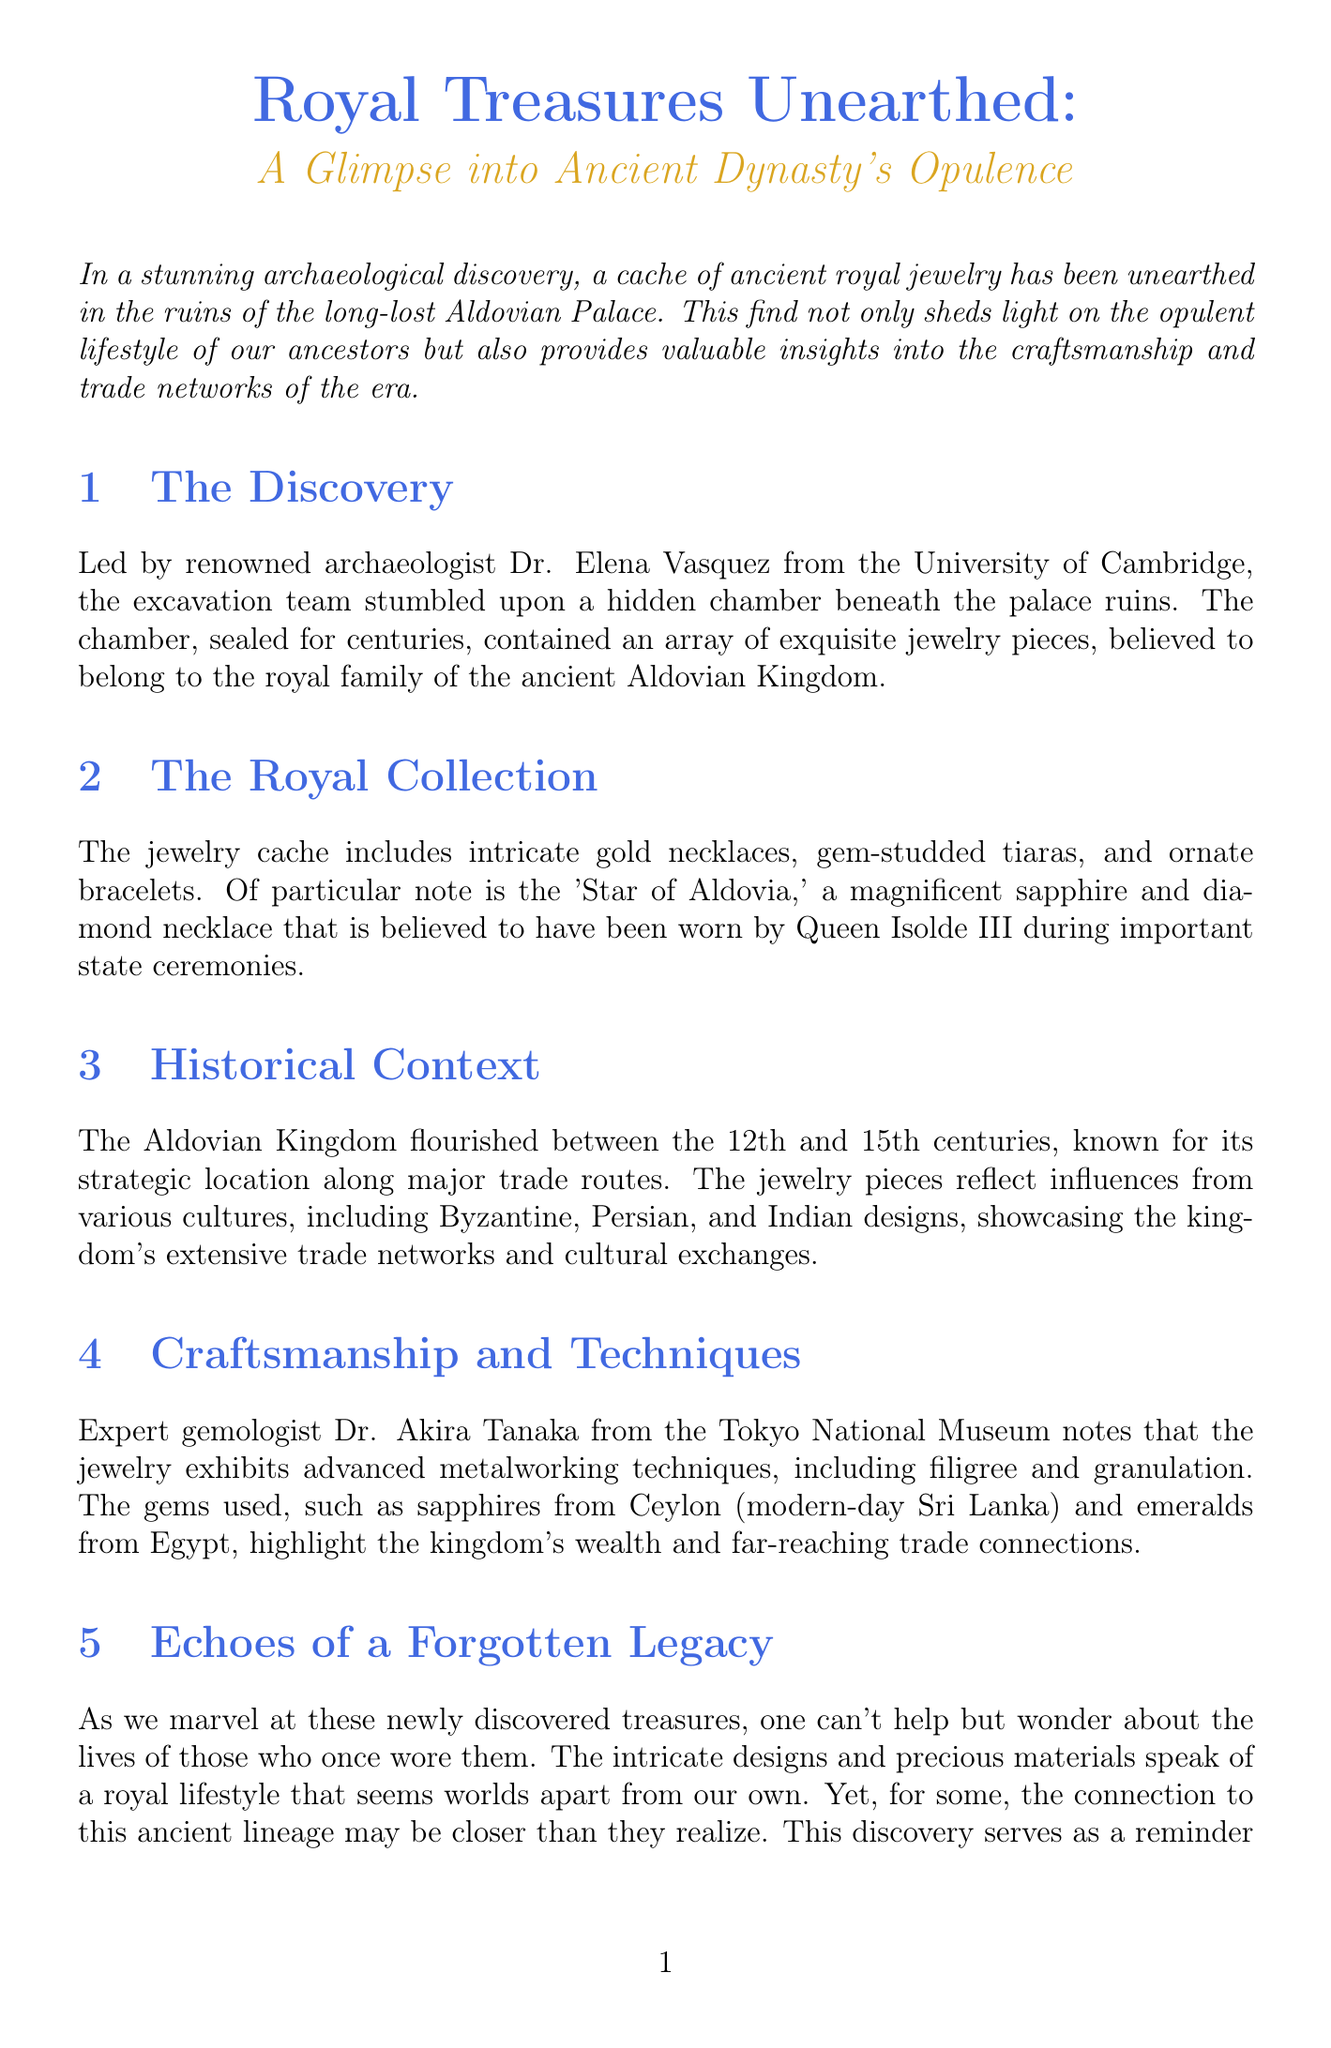What is the title of the newsletter? The title of the newsletter is the first piece of information presented.
Answer: Royal Treasures Unearthed: A Glimpse into Ancient Dynasty's Opulence Who led the excavation team? The document credits renowned archaeologist Dr. Elena Vasquez with leading the excavation.
Answer: Dr. Elena Vasquez What notable piece of jewelry is mentioned? The document specifically highlights the 'Star of Aldovia,' a notable jewelry piece.
Answer: Star of Aldovia During which centuries did the Aldovian Kingdom flourish? The document states that the Aldovian Kingdom flourished between the 12th and 15th centuries.
Answer: 12th and 15th centuries Which materials are mentioned in the craftsmanship section? The craftsmanship section details specific gems associated with the jewelry, indicating their origin.
Answer: sapphires and emeralds What is the focus of the persona tailored section? The persona tailored section discusses a connection to royal ancestry, emphasizing the impact of the discovery.
Answer: connection to royal ancestry What archaeological feature was discovered? The document notes that a hidden chamber was discovered during the excavation.
Answer: hidden chamber What is the date of the upcoming lecture? The upcoming lecture date is stated in the additional resources section of the document.
Answer: May 15th 